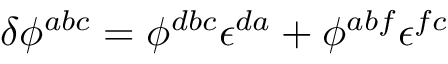<formula> <loc_0><loc_0><loc_500><loc_500>\delta \phi ^ { a b c } = \phi ^ { d b c } \epsilon ^ { d a } + \phi ^ { a b f } \epsilon ^ { f c }</formula> 